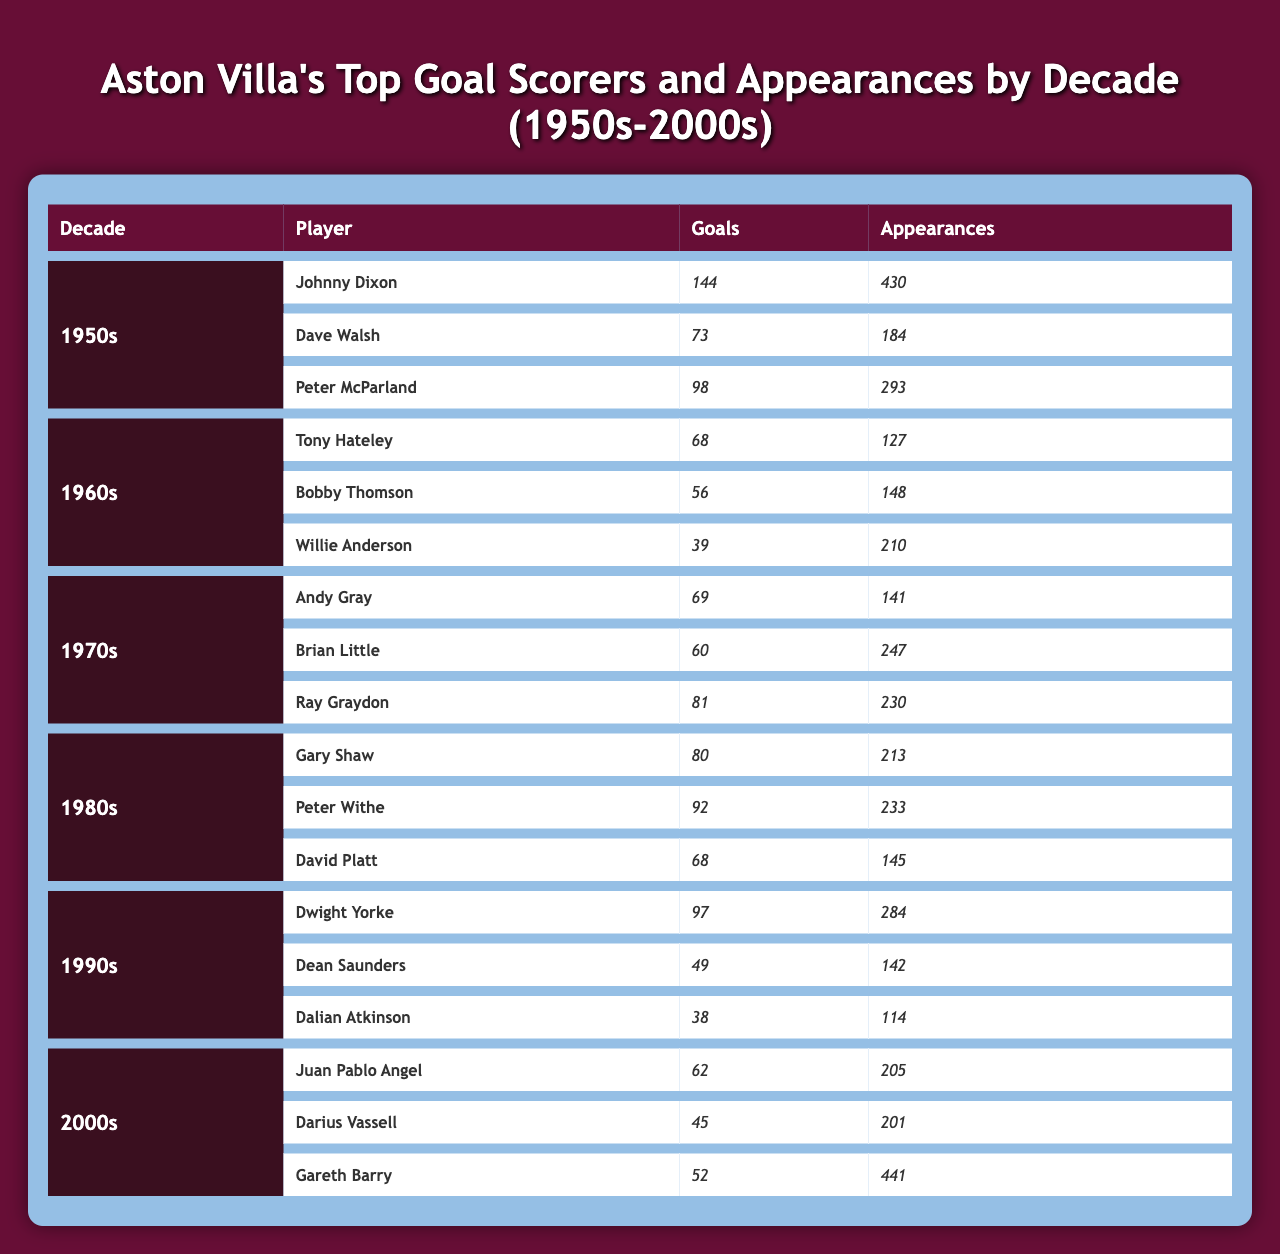What decade did Johnny Dixon score the most goals? Johnny Dixon scored the highest number of goals in the 1950s, with a total of 144 goals.
Answer: 1950s Who was the top goal scorer in the 1980s? The top goal scorer in the 1980s was Peter Withe, who scored 92 goals.
Answer: Peter Withe How many goals did Dwight Yorke score in the 1990s? Dwight Yorke scored 97 goals in the 1990s, making him one of the top scorers of that decade.
Answer: 97 Which player had the most appearances in the 2000s? Gareth Barry had the most appearances in the 2000s, with a total of 441 appearances.
Answer: Gareth Barry What is the total number of goals scored by the top scorers of the 1970s? The total number of goals scored by the top scorers in the 1970s is 210, calculated by adding the goals from Andy Gray (69), Brian Little (60), and Ray Graydon (81): 69 + 60 + 81 = 210.
Answer: 210 Did any player in the 1990s score more than 50 goals? Yes, Dwight Yorke scored 97 goals, which is more than 50.
Answer: Yes What is the average number of goals scored by top goal scorers in the 1980s? The average number of goals scored by the top goal scorers in the 1980s is 80. When summing the goals (80 + 92 + 68 = 240) and dividing by 3 (240/3 = 80), we find the average.
Answer: 80 Which decade had the highest total appearances by top goal scorers? The 2000s had the highest total appearances by top goal scorers, with 441 (Gareth Barry) + 205 (Juan Pablo Angel) + 201 (Darius Vassell) totaling 847 appearances.
Answer: 2000s How many goals did the second top scorer of the 1960s have? The second top scorer in the 1960s was Bobby Thomson, who scored 56 goals.
Answer: 56 Is the total number of appearances by top scorers in the 1950s greater than 1000? Yes, the total appearances are 430 (Johnny Dixon) + 184 (Dave Walsh) + 293 (Peter McParland) = 907, which is less than 1000. Thus, the answer is no.
Answer: No Which player had the most goals in the 1950s and how many? Johnny Dixon had the most goals in the 1950s with a total of 144 goals.
Answer: Johnny Dixon, 144 